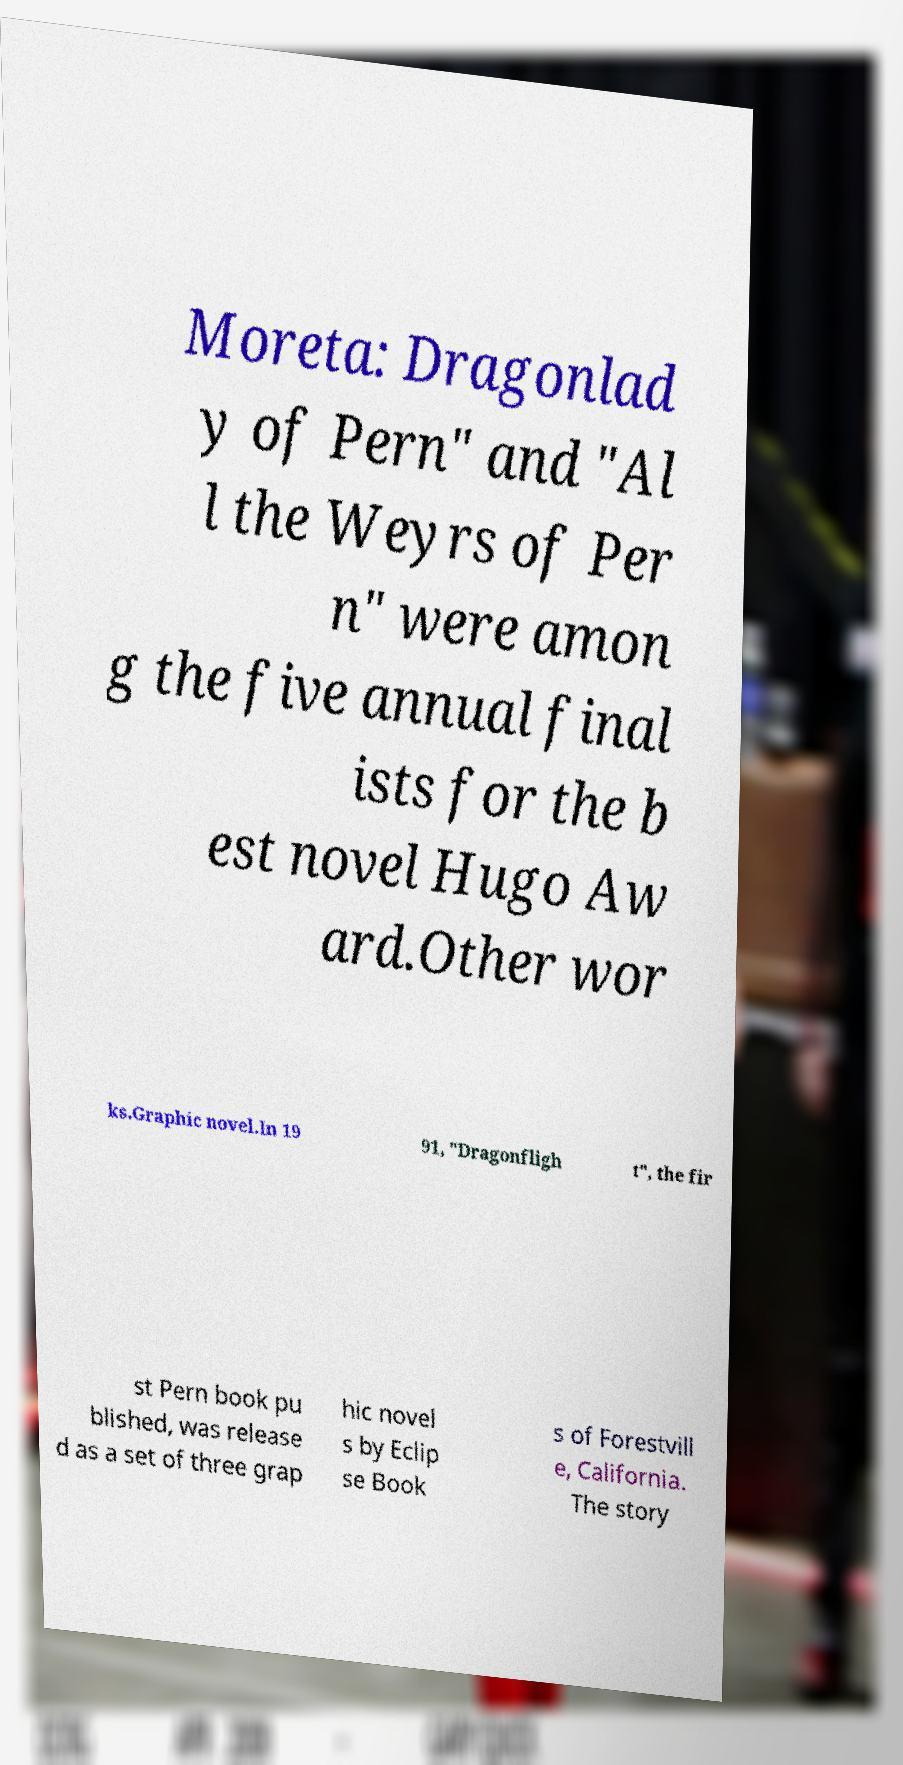Could you assist in decoding the text presented in this image and type it out clearly? Moreta: Dragonlad y of Pern" and "Al l the Weyrs of Per n" were amon g the five annual final ists for the b est novel Hugo Aw ard.Other wor ks.Graphic novel.In 19 91, "Dragonfligh t", the fir st Pern book pu blished, was release d as a set of three grap hic novel s by Eclip se Book s of Forestvill e, California. The story 